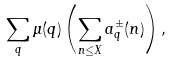<formula> <loc_0><loc_0><loc_500><loc_500>\sum _ { q } \mu ( q ) \left ( \sum _ { n \leq X } a ^ { \pm } _ { q } ( n ) \right ) ,</formula> 